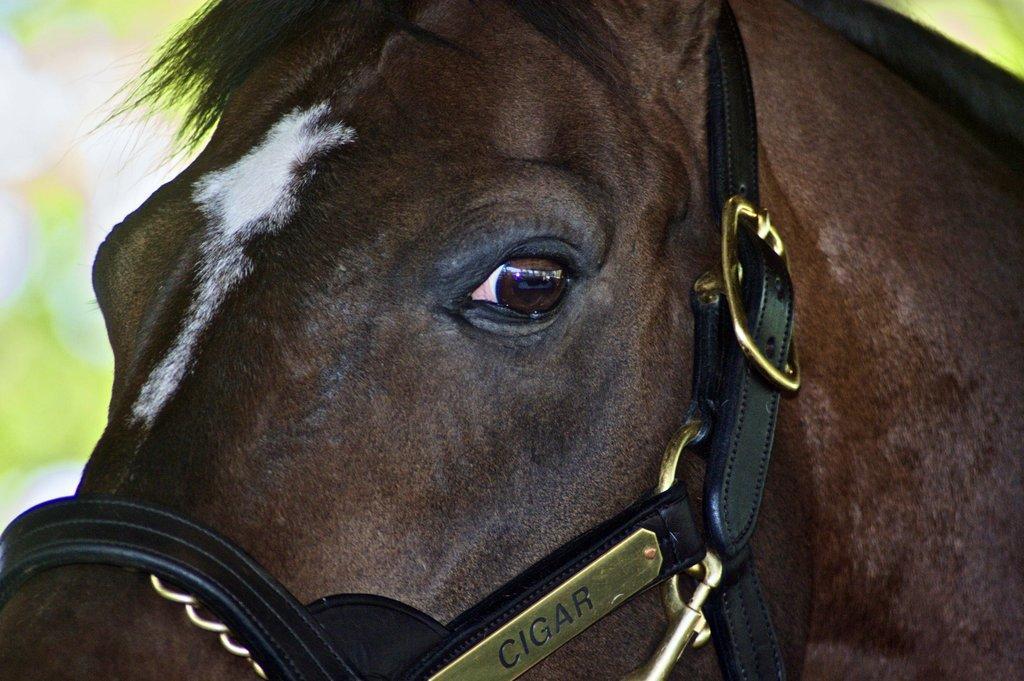Can you describe this image briefly? In this image I can see a brown colour horse, I can also see black belt and over here I can see something is written. I can also see green colour in background and I can see this image is blurry from background. 